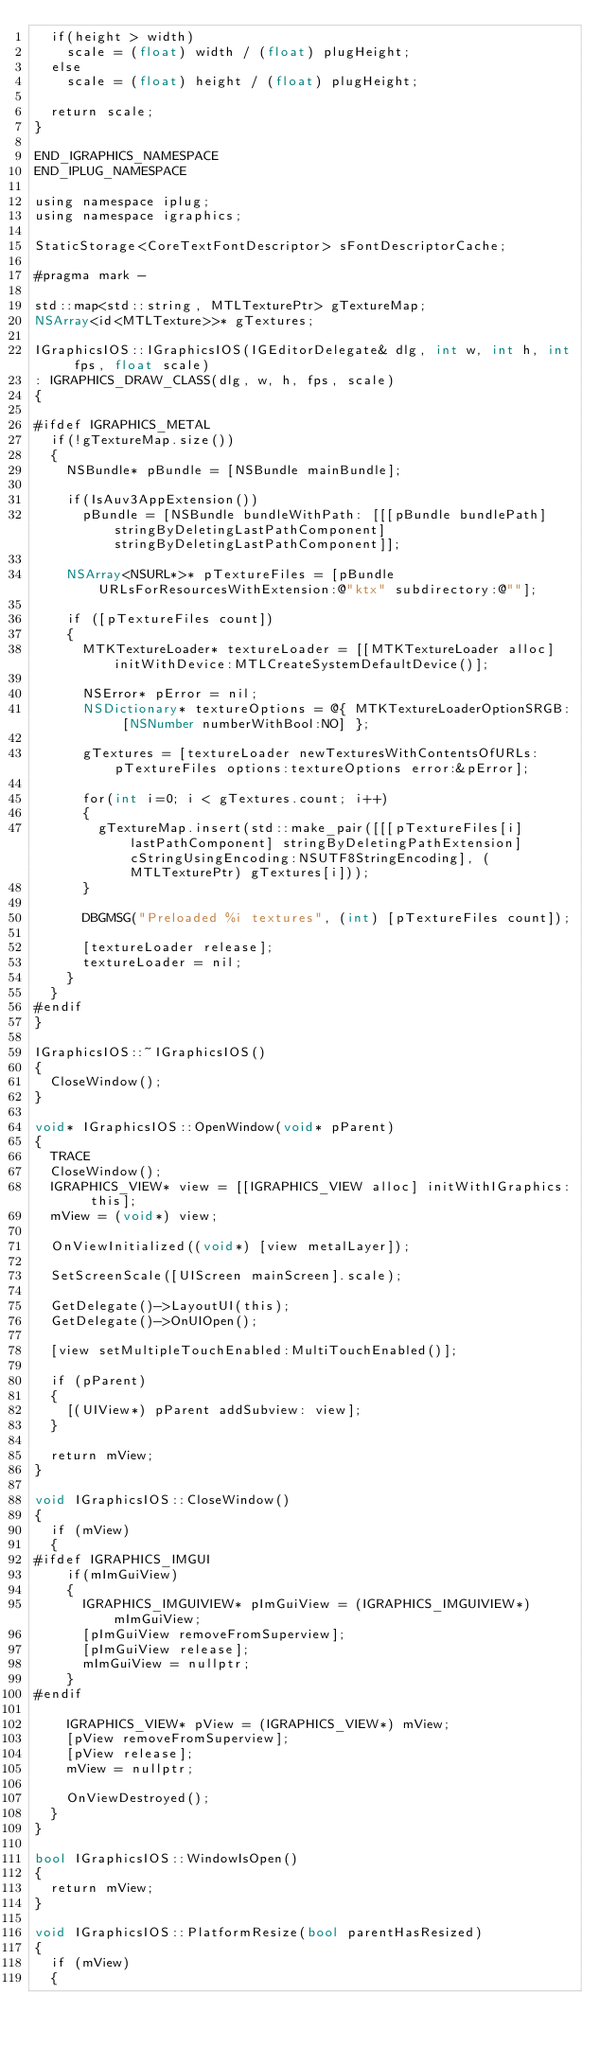<code> <loc_0><loc_0><loc_500><loc_500><_ObjectiveC_>  if(height > width)
    scale = (float) width / (float) plugHeight;
  else
    scale = (float) height / (float) plugHeight;
  
  return scale;
}

END_IGRAPHICS_NAMESPACE
END_IPLUG_NAMESPACE

using namespace iplug;
using namespace igraphics;

StaticStorage<CoreTextFontDescriptor> sFontDescriptorCache;

#pragma mark -

std::map<std::string, MTLTexturePtr> gTextureMap;
NSArray<id<MTLTexture>>* gTextures;

IGraphicsIOS::IGraphicsIOS(IGEditorDelegate& dlg, int w, int h, int fps, float scale)
: IGRAPHICS_DRAW_CLASS(dlg, w, h, fps, scale)
{
 
#ifdef IGRAPHICS_METAL
  if(!gTextureMap.size())
  {
    NSBundle* pBundle = [NSBundle mainBundle];

    if(IsAuv3AppExtension())
      pBundle = [NSBundle bundleWithPath: [[[pBundle bundlePath] stringByDeletingLastPathComponent] stringByDeletingLastPathComponent]];
    
    NSArray<NSURL*>* pTextureFiles = [pBundle URLsForResourcesWithExtension:@"ktx" subdirectory:@""];
    
    if ([pTextureFiles count])
    {
      MTKTextureLoader* textureLoader = [[MTKTextureLoader alloc] initWithDevice:MTLCreateSystemDefaultDevice()];
      
      NSError* pError = nil;
      NSDictionary* textureOptions = @{ MTKTextureLoaderOptionSRGB: [NSNumber numberWithBool:NO] };

      gTextures = [textureLoader newTexturesWithContentsOfURLs:pTextureFiles options:textureOptions error:&pError];
    
      for(int i=0; i < gTextures.count; i++)
      {
        gTextureMap.insert(std::make_pair([[[pTextureFiles[i] lastPathComponent] stringByDeletingPathExtension] cStringUsingEncoding:NSUTF8StringEncoding], (MTLTexturePtr) gTextures[i]));
      }
    
      DBGMSG("Preloaded %i textures", (int) [pTextureFiles count]);
    
      [textureLoader release];
      textureLoader = nil;
    }
  }
#endif
}

IGraphicsIOS::~IGraphicsIOS()
{
  CloseWindow();
}

void* IGraphicsIOS::OpenWindow(void* pParent)
{
  TRACE
  CloseWindow();
  IGRAPHICS_VIEW* view = [[IGRAPHICS_VIEW alloc] initWithIGraphics: this];
  mView = (void*) view;
  
  OnViewInitialized((void*) [view metalLayer]);
  
  SetScreenScale([UIScreen mainScreen].scale);
  
  GetDelegate()->LayoutUI(this);
  GetDelegate()->OnUIOpen();
  
  [view setMultipleTouchEnabled:MultiTouchEnabled()];

  if (pParent)
  {
    [(UIView*) pParent addSubview: view];
  }

  return mView;
}

void IGraphicsIOS::CloseWindow()
{
  if (mView)
  {
#ifdef IGRAPHICS_IMGUI
    if(mImGuiView)
    {
      IGRAPHICS_IMGUIVIEW* pImGuiView = (IGRAPHICS_IMGUIVIEW*) mImGuiView;
      [pImGuiView removeFromSuperview];
      [pImGuiView release];
      mImGuiView = nullptr;
    }
#endif
    
    IGRAPHICS_VIEW* pView = (IGRAPHICS_VIEW*) mView;
    [pView removeFromSuperview];
    [pView release];
    mView = nullptr;

    OnViewDestroyed();
  }
}

bool IGraphicsIOS::WindowIsOpen()
{
  return mView;
}

void IGraphicsIOS::PlatformResize(bool parentHasResized)
{
  if (mView)
  {</code> 